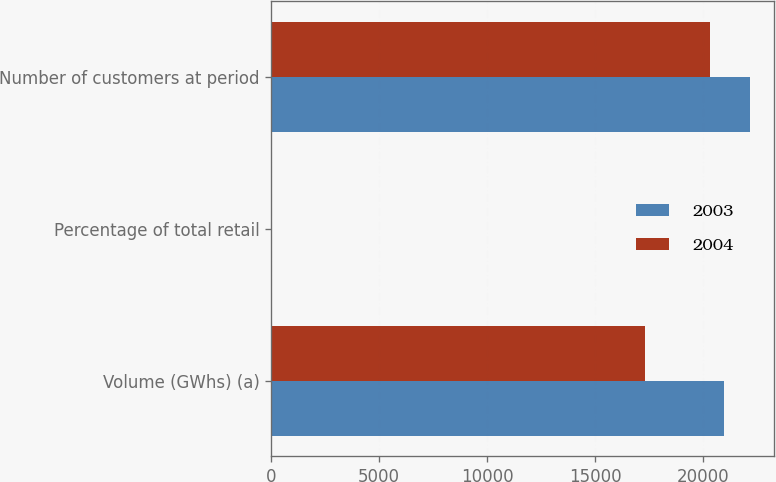Convert chart. <chart><loc_0><loc_0><loc_500><loc_500><stacked_bar_chart><ecel><fcel>Volume (GWhs) (a)<fcel>Percentage of total retail<fcel>Number of customers at period<nl><fcel>2003<fcel>20939<fcel>24<fcel>22161<nl><fcel>2004<fcel>17317<fcel>20<fcel>20300<nl></chart> 